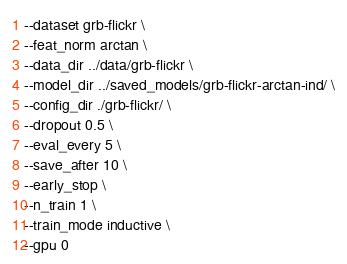Convert code to text. <code><loc_0><loc_0><loc_500><loc_500><_Bash_>--dataset grb-flickr \
--feat_norm arctan \
--data_dir ../data/grb-flickr \
--model_dir ../saved_models/grb-flickr-arctan-ind/ \
--config_dir ./grb-flickr/ \
--dropout 0.5 \
--eval_every 5 \
--save_after 10 \
--early_stop \
--n_train 1 \
--train_mode inductive \
--gpu 0</code> 